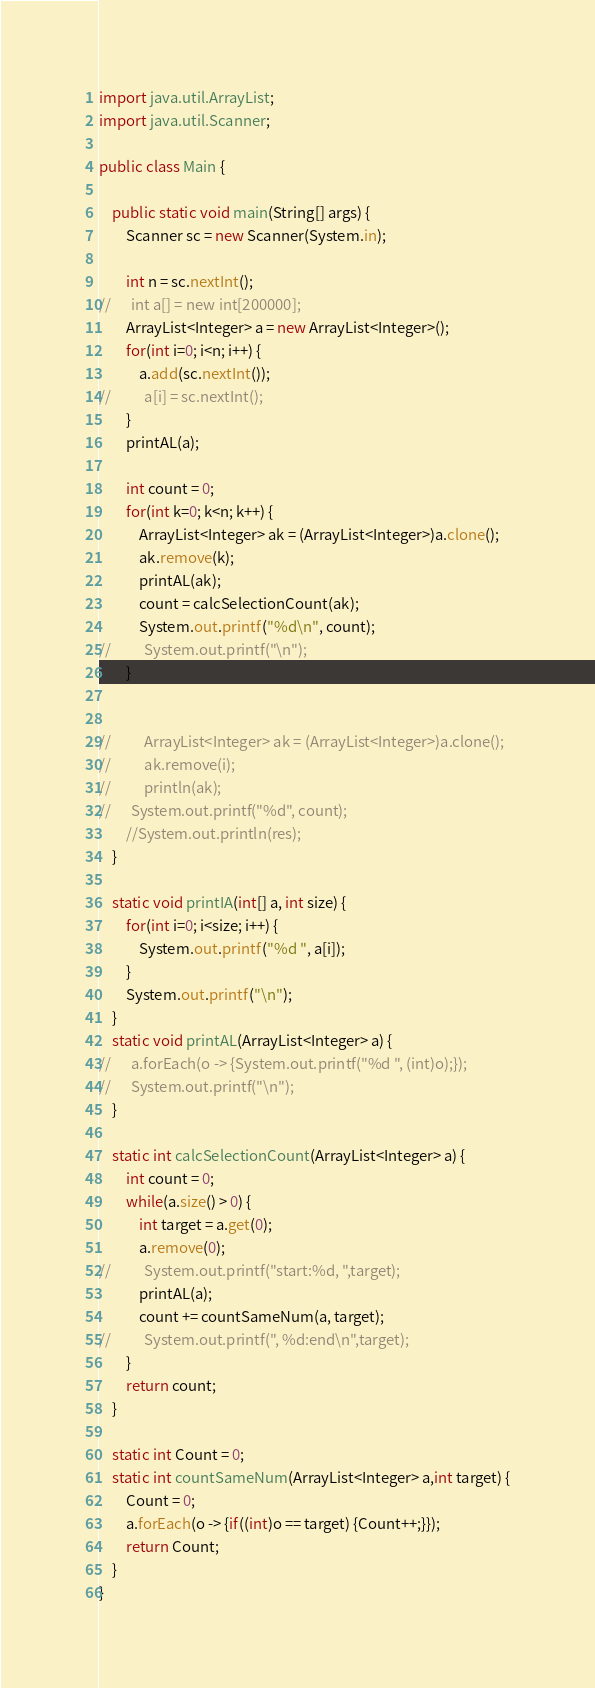<code> <loc_0><loc_0><loc_500><loc_500><_Java_>import java.util.ArrayList;
import java.util.Scanner;

public class Main {

	public static void main(String[] args) {
		Scanner sc = new Scanner(System.in);

		int n = sc.nextInt();
//		int a[] = new int[200000];
		ArrayList<Integer> a = new ArrayList<Integer>();
		for(int i=0; i<n; i++) {
			a.add(sc.nextInt());
//			a[i] = sc.nextInt();
		}
		printAL(a);

		int count = 0;
		for(int k=0; k<n; k++) {
			ArrayList<Integer> ak = (ArrayList<Integer>)a.clone();
			ak.remove(k);
			printAL(ak);
			count = calcSelectionCount(ak);
			System.out.printf("%d\n", count);
//			System.out.printf("\n");
		}


//			ArrayList<Integer> ak = (ArrayList<Integer>)a.clone();
//			ak.remove(i);
//			println(ak);
//		System.out.printf("%d", count);
		//System.out.println(res);
	}

	static void printIA(int[] a, int size) {
		for(int i=0; i<size; i++) {
			System.out.printf("%d ", a[i]);
		}
		System.out.printf("\n");
	}
	static void printAL(ArrayList<Integer> a) {
//		a.forEach(o -> {System.out.printf("%d ", (int)o);});
//		System.out.printf("\n");
	}

	static int calcSelectionCount(ArrayList<Integer> a) {
		int count = 0;
		while(a.size() > 0) {
			int target = a.get(0);
			a.remove(0);
//			System.out.printf("start:%d, ",target);
			printAL(a);
			count += countSameNum(a, target);
//			System.out.printf(", %d:end\n",target);
		}
		return count;
	}

	static int Count = 0;
	static int countSameNum(ArrayList<Integer> a,int target) {
		Count = 0;
		a.forEach(o -> {if((int)o == target) {Count++;}});
		return Count;
	}
}


</code> 